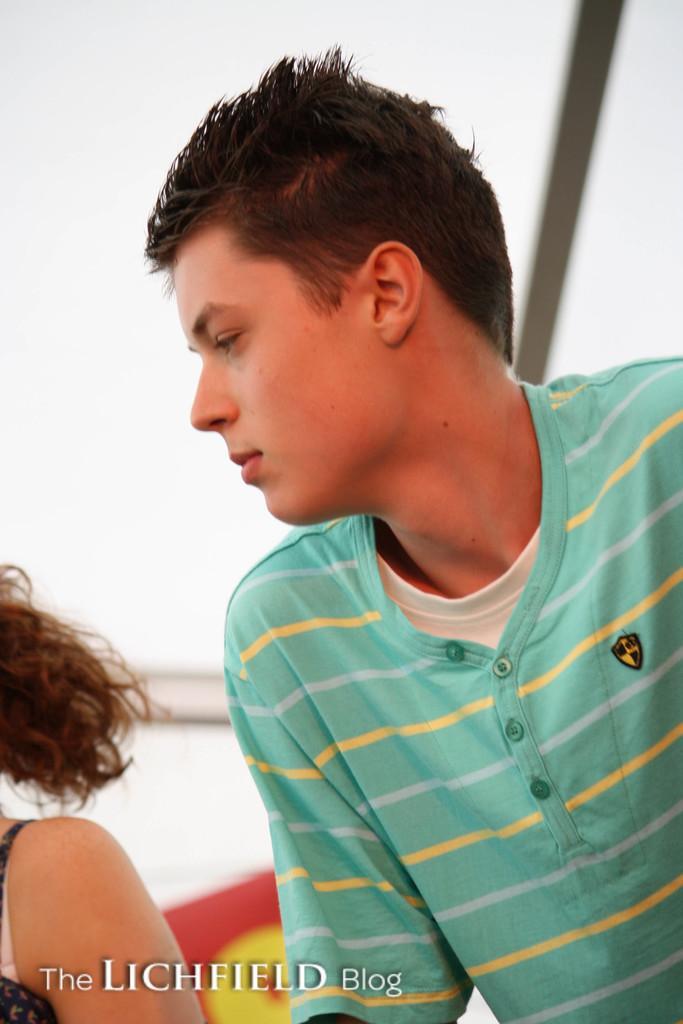How would you summarize this image in a sentence or two? In this image I can see a person standing, behind him there is another person and water mark at the bottom of image. 